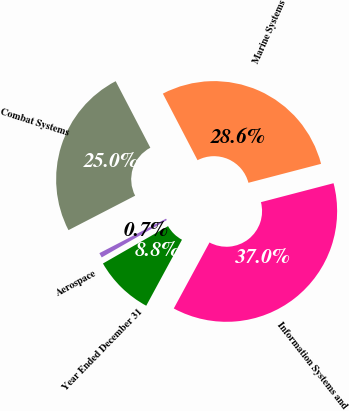Convert chart. <chart><loc_0><loc_0><loc_500><loc_500><pie_chart><fcel>Year Ended December 31<fcel>Aerospace<fcel>Combat Systems<fcel>Marine Systems<fcel>Information Systems and<nl><fcel>8.81%<fcel>0.7%<fcel>24.95%<fcel>28.58%<fcel>36.96%<nl></chart> 